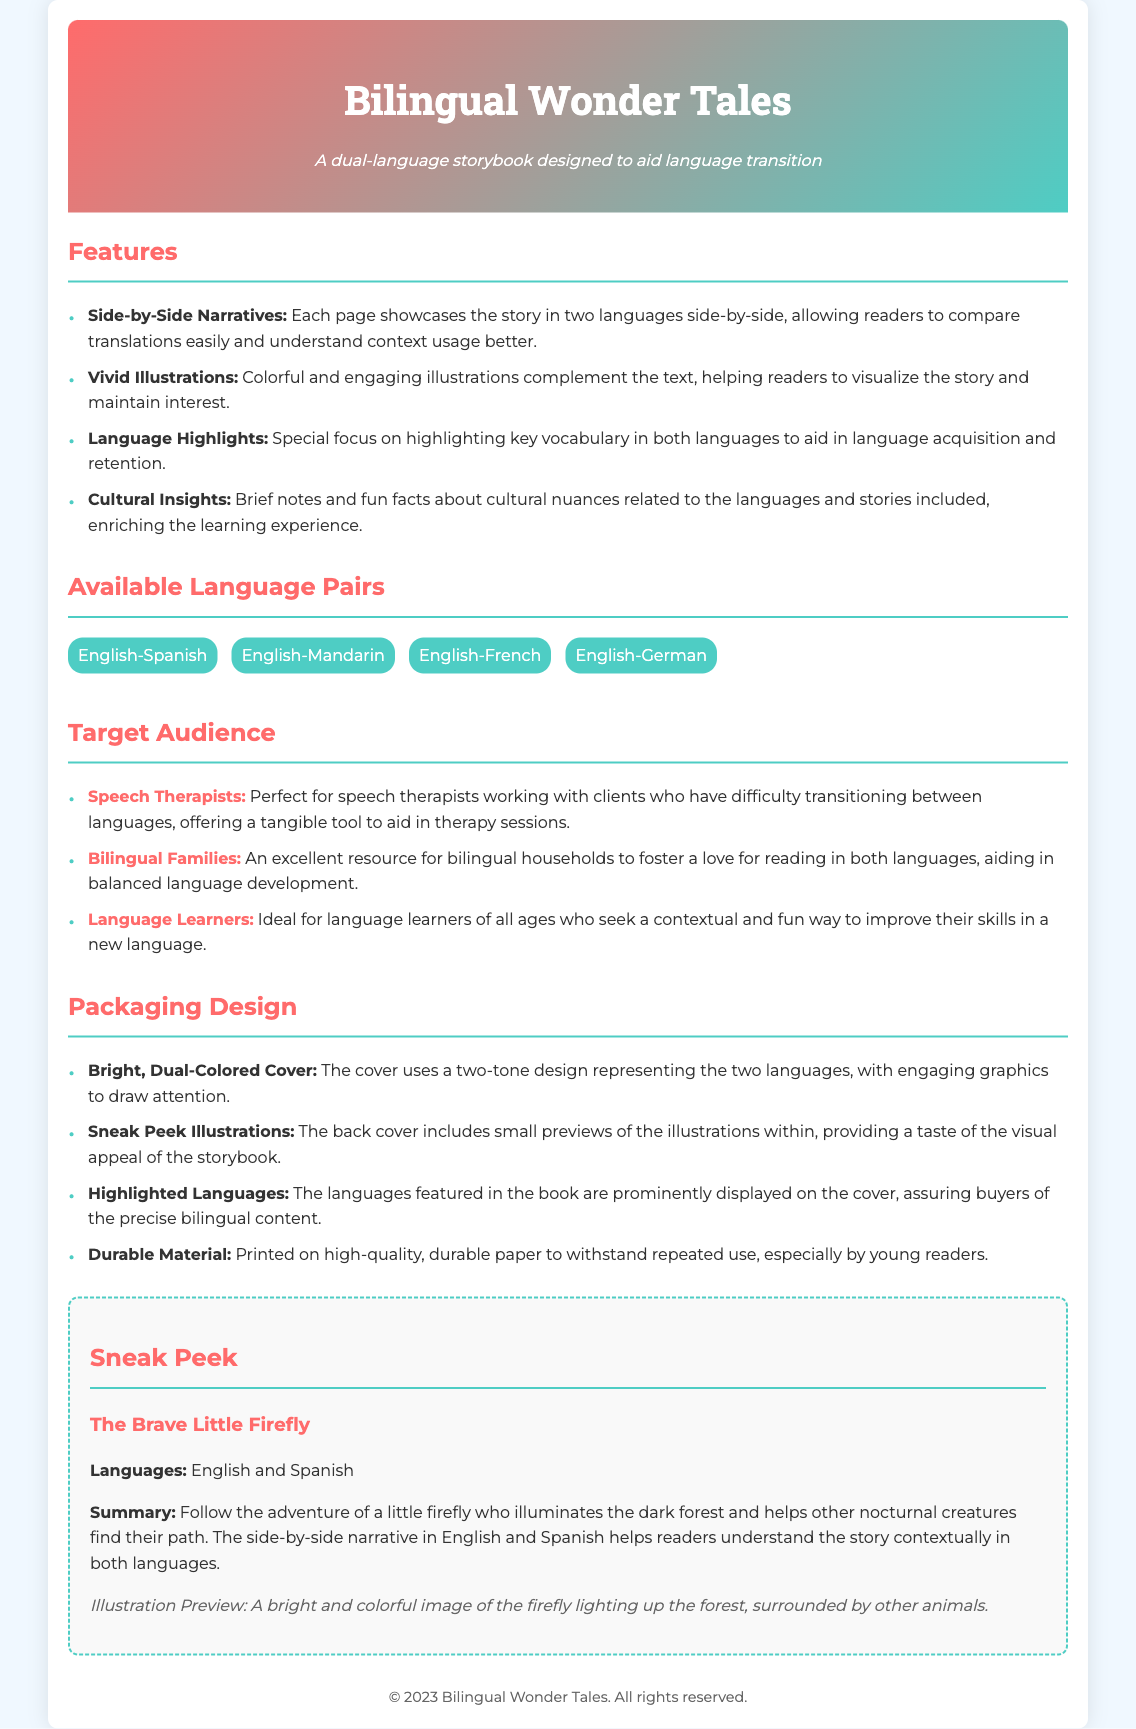What is the title of the storybook? The title of the storybook is given in the header section of the document.
Answer: Bilingual Wonder Tales What are the two featured languages in the sneak peek? The languages in the sneak peek are listed under the "Sneak Peek" section.
Answer: English and Spanish How many features are listed in the document? The features are enumerated in a list format. The total count can be determined by counting the items.
Answer: Four Which audience is specifically mentioned as a target for using the storybook? The target audiences are highlighted in a separate section with specific labels.
Answer: Speech Therapists What design element is used to highlight the languages on the cover? The document describes the packaging design with a specific emphasis on the cover.
Answer: Bright, Dual-Colored Cover What is the main theme of "The Brave Little Firefly"? The theme is summarized in the sneak peek section of the document, explaining the story's focus.
Answer: Adventure of a little firefly How many language pairs are available? The number of unique language pairs is mentioned in the "Available Language Pairs" section.
Answer: Four What type of illustrations accompany the text? The description of the illustrations is provided in the features section of the document.
Answer: Vivid Illustrations What unique feature aids in vocabulary learning in the book? The document highlights specific features that focus on vocabulary.
Answer: Language Highlights 